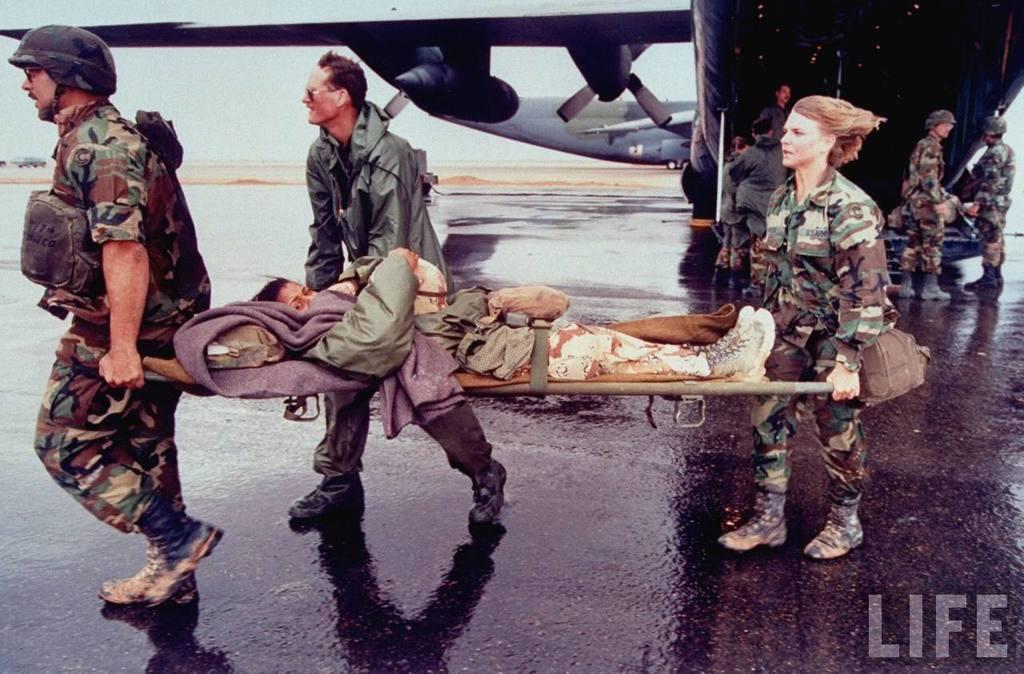Please provide a concise description of this image. In this picture I can see a man who is wearing helmet, spectacle, shirt, trouser and shoe. On the right there is a woman who is wearing army uniform. Both of them are holding the bed. In that there is a woman who is lying on bed. Beside them there is a man who is wearing jacket, trouser and shoes. In the background I can see the plane which is parked on the runway. Beside that I can see many army people were standing. On the left background I can see the car, open land, ocean and sky. In the bottom right corner there is a watermark. 